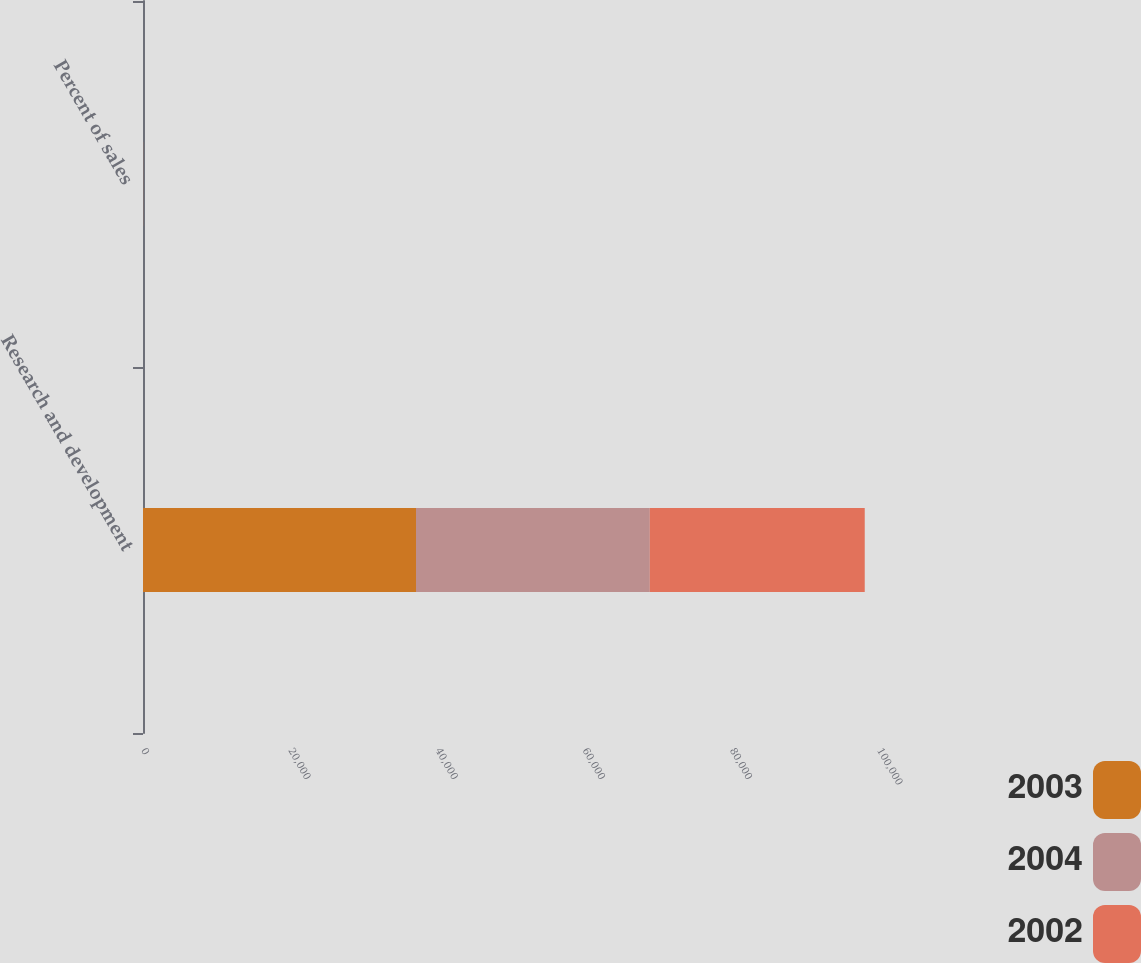Convert chart. <chart><loc_0><loc_0><loc_500><loc_500><stacked_bar_chart><ecel><fcel>Research and development<fcel>Percent of sales<nl><fcel>2003<fcel>37093<fcel>5.6<nl><fcel>2004<fcel>31759<fcel>5.9<nl><fcel>2002<fcel>29210<fcel>6.1<nl></chart> 